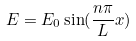<formula> <loc_0><loc_0><loc_500><loc_500>E = E _ { 0 } \sin ( \frac { n \pi } { L } x )</formula> 